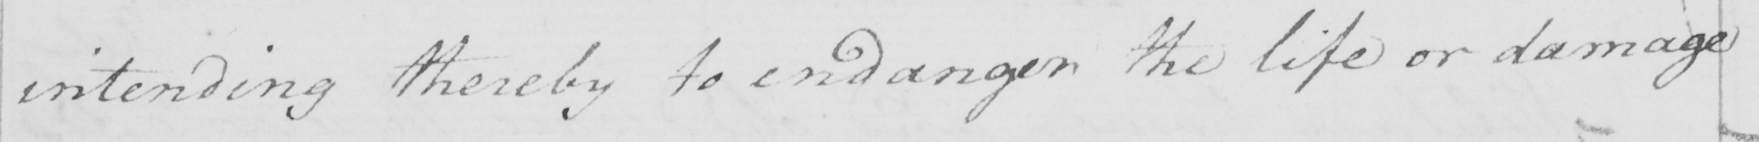Transcribe the text shown in this historical manuscript line. intending thereby to endanger the life or damage 